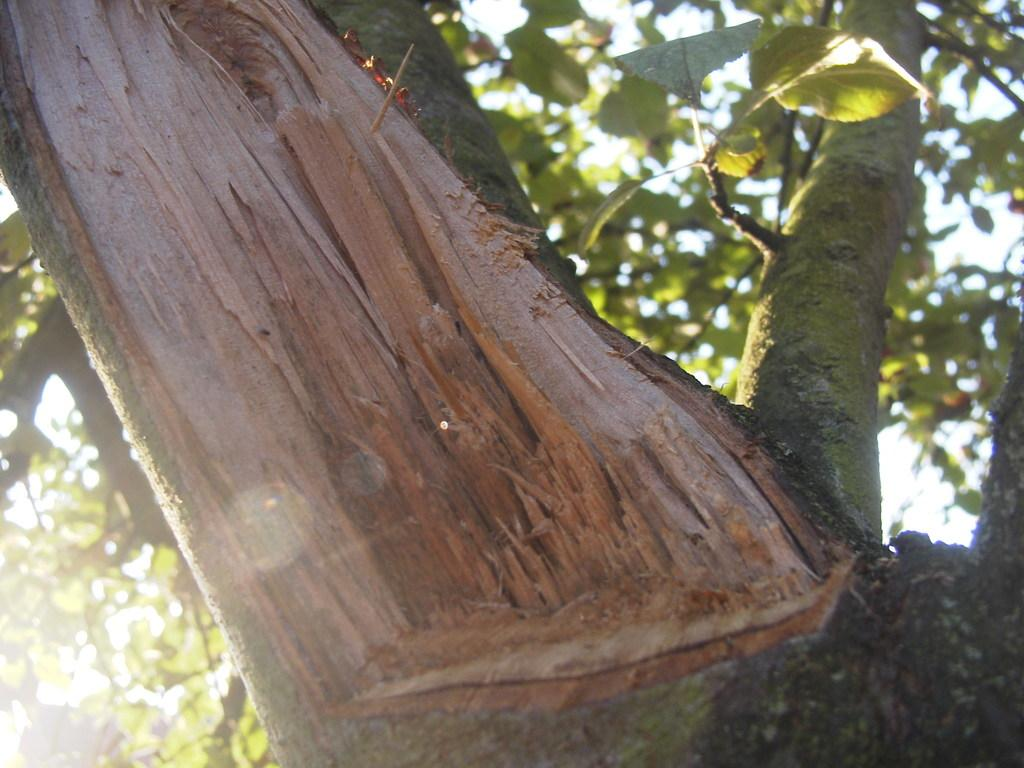What type of plant can be seen in the image? There is a tree in the image. What part of the natural environment is visible in the image? The sky is visible in the background of the image. How many ants are crawling on the tree in the image? There are no ants visible in the image; it only features a tree and the sky. Is there a bear playing volleyball with the tree in the image? There is no bear or volleyball present in the image; it only features a tree and the sky. 